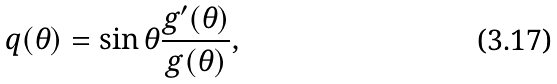<formula> <loc_0><loc_0><loc_500><loc_500>q ( \theta ) = \sin \theta \frac { g ^ { \prime } ( \theta ) } { g ( \theta ) } ,</formula> 